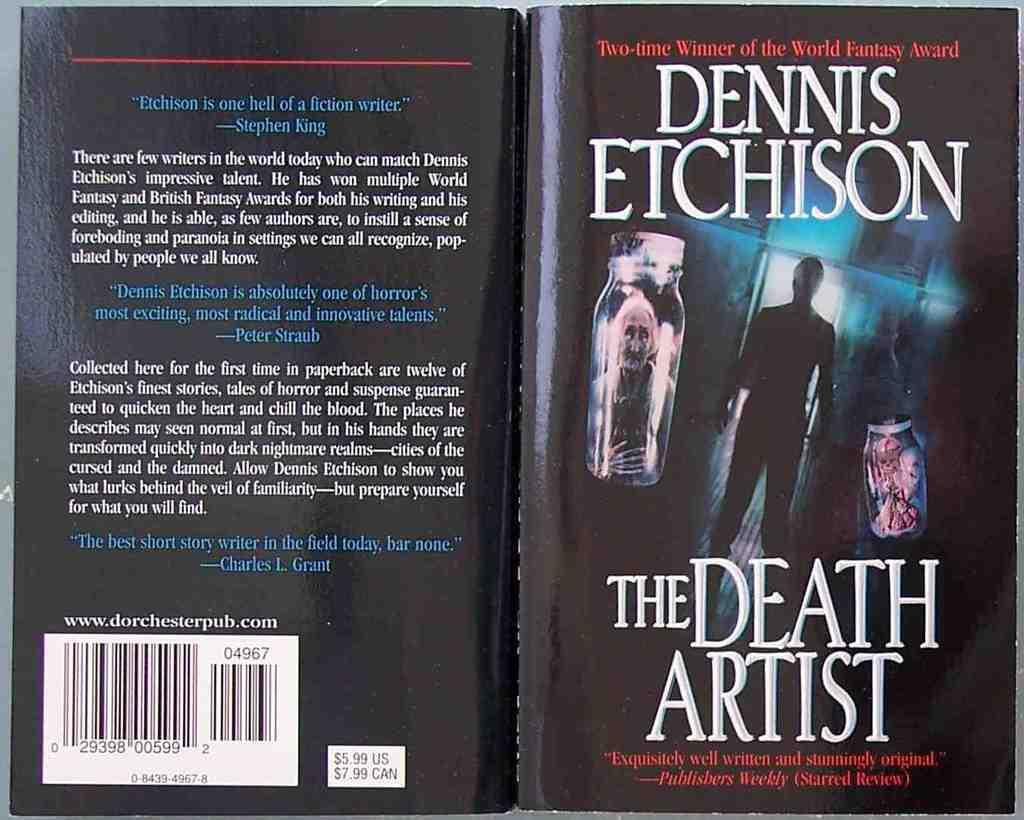Provide a one-sentence caption for the provided image. A Dennis Etchison novel called the Death Artist. 